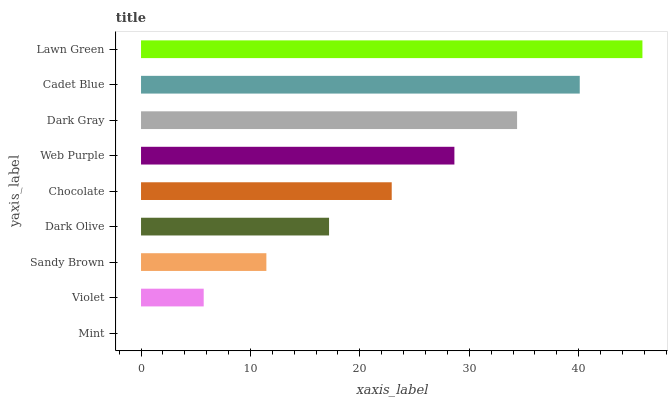Is Mint the minimum?
Answer yes or no. Yes. Is Lawn Green the maximum?
Answer yes or no. Yes. Is Violet the minimum?
Answer yes or no. No. Is Violet the maximum?
Answer yes or no. No. Is Violet greater than Mint?
Answer yes or no. Yes. Is Mint less than Violet?
Answer yes or no. Yes. Is Mint greater than Violet?
Answer yes or no. No. Is Violet less than Mint?
Answer yes or no. No. Is Chocolate the high median?
Answer yes or no. Yes. Is Chocolate the low median?
Answer yes or no. Yes. Is Cadet Blue the high median?
Answer yes or no. No. Is Lawn Green the low median?
Answer yes or no. No. 